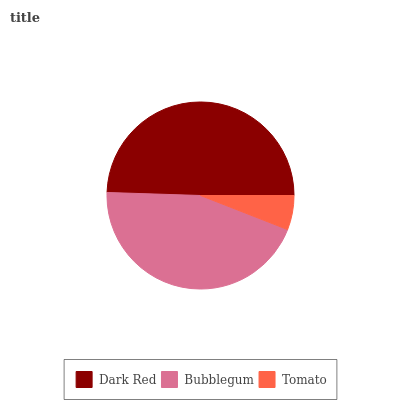Is Tomato the minimum?
Answer yes or no. Yes. Is Dark Red the maximum?
Answer yes or no. Yes. Is Bubblegum the minimum?
Answer yes or no. No. Is Bubblegum the maximum?
Answer yes or no. No. Is Dark Red greater than Bubblegum?
Answer yes or no. Yes. Is Bubblegum less than Dark Red?
Answer yes or no. Yes. Is Bubblegum greater than Dark Red?
Answer yes or no. No. Is Dark Red less than Bubblegum?
Answer yes or no. No. Is Bubblegum the high median?
Answer yes or no. Yes. Is Bubblegum the low median?
Answer yes or no. Yes. Is Tomato the high median?
Answer yes or no. No. Is Dark Red the low median?
Answer yes or no. No. 